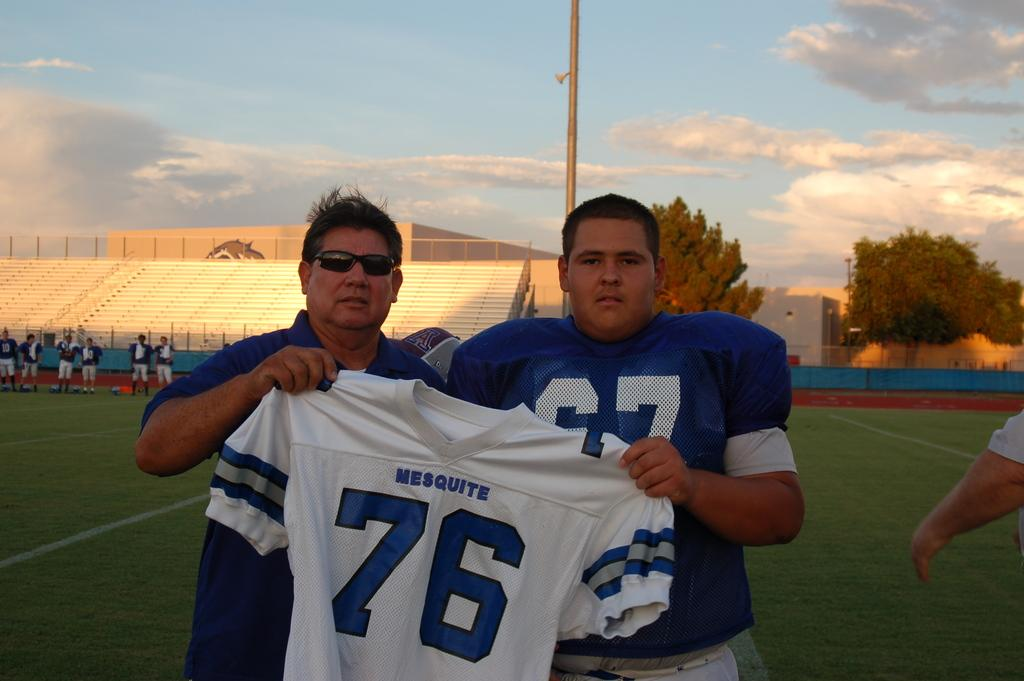<image>
Present a compact description of the photo's key features. Two men on a football field holding up a Mesquite jersey with the number 76 